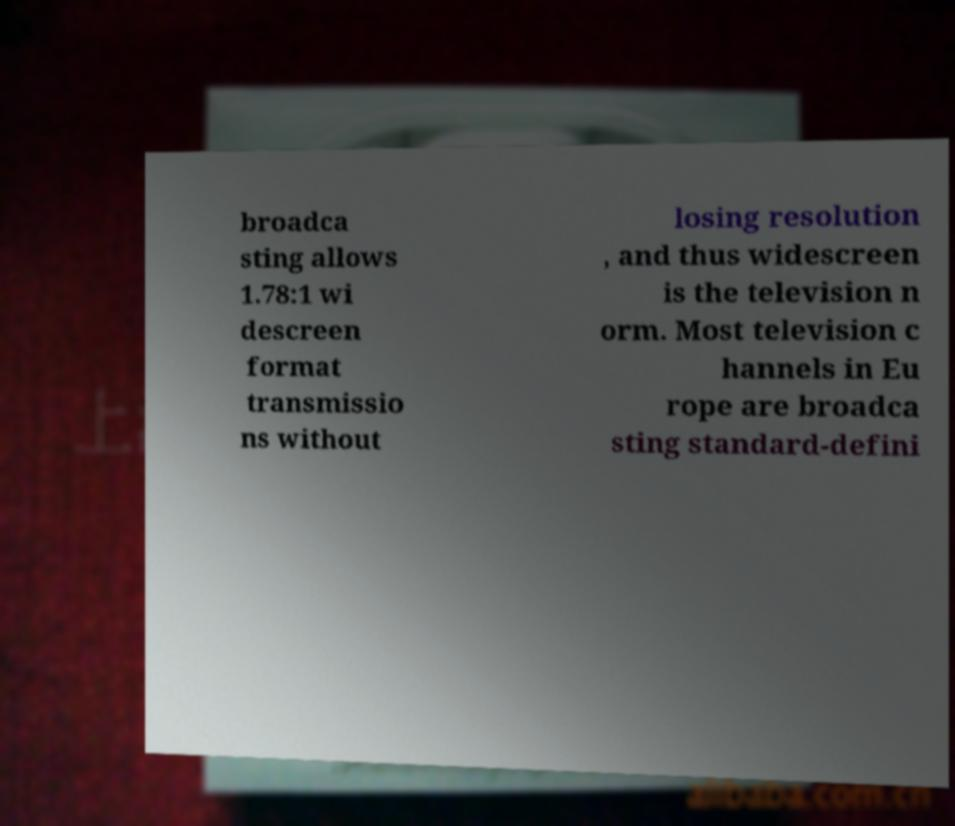Please identify and transcribe the text found in this image. broadca sting allows 1.78:1 wi descreen format transmissio ns without losing resolution , and thus widescreen is the television n orm. Most television c hannels in Eu rope are broadca sting standard-defini 